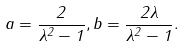<formula> <loc_0><loc_0><loc_500><loc_500>a = \frac { 2 } { \lambda ^ { 2 } - 1 } , b = \frac { 2 \lambda } { \lambda ^ { 2 } - 1 } .</formula> 